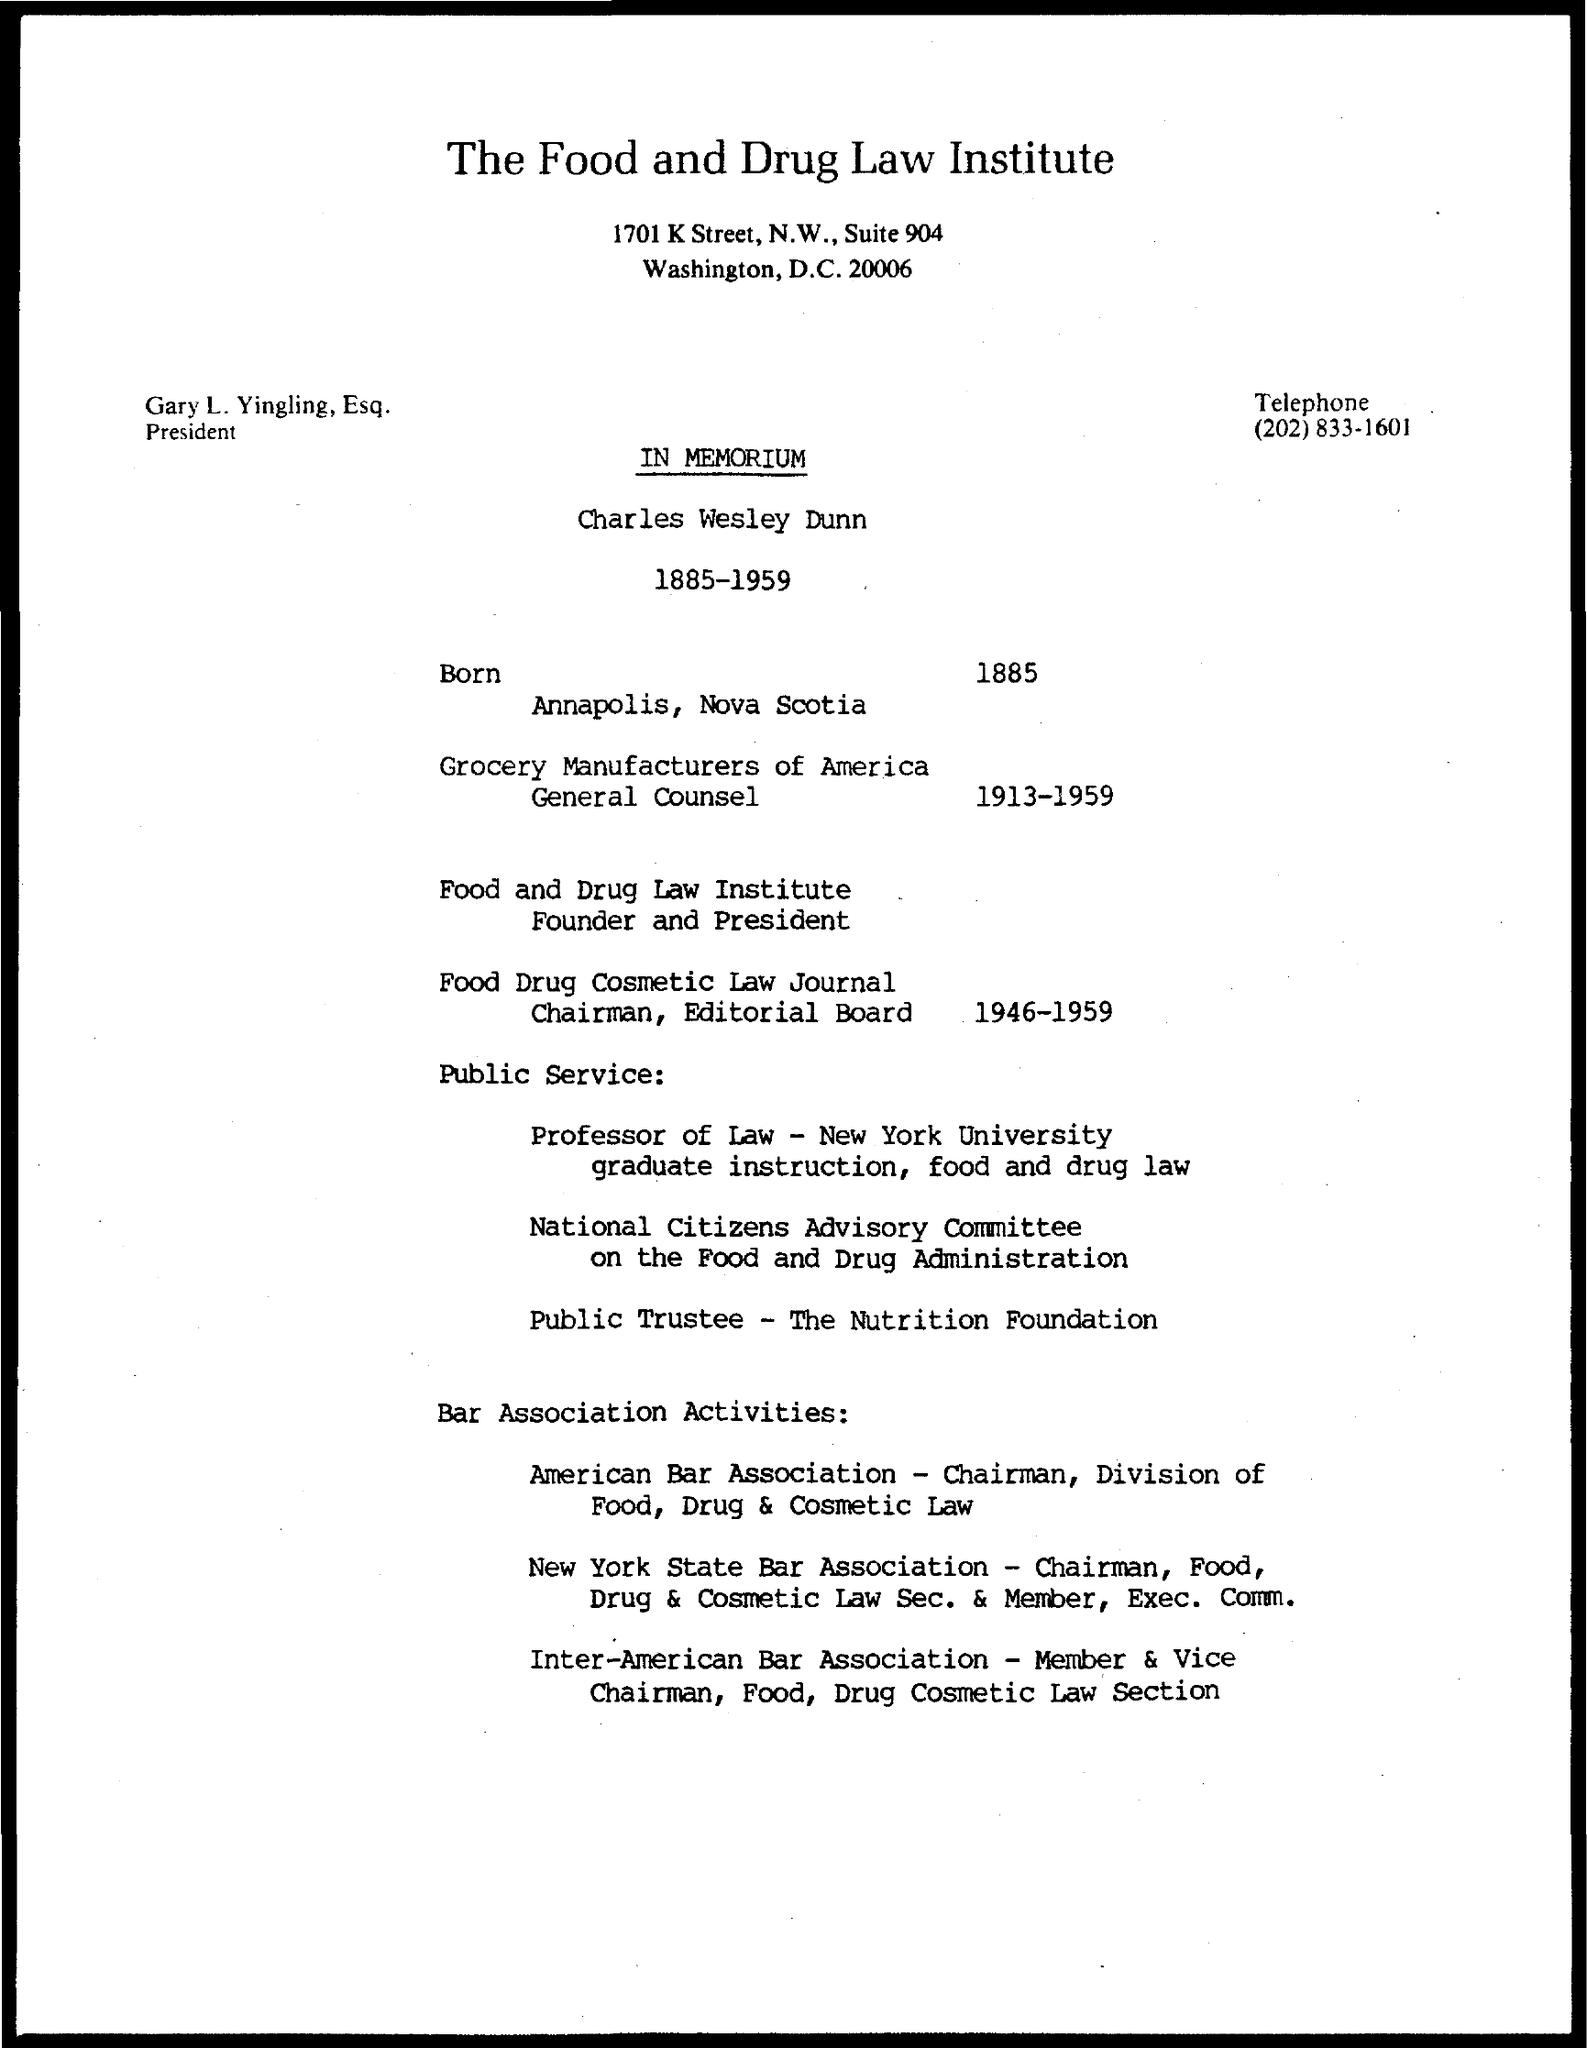Mention a couple of crucial points in this snapshot. The telephone number mentioned in the document is (202) 833-1601. What is the title of the document in memoriam? 